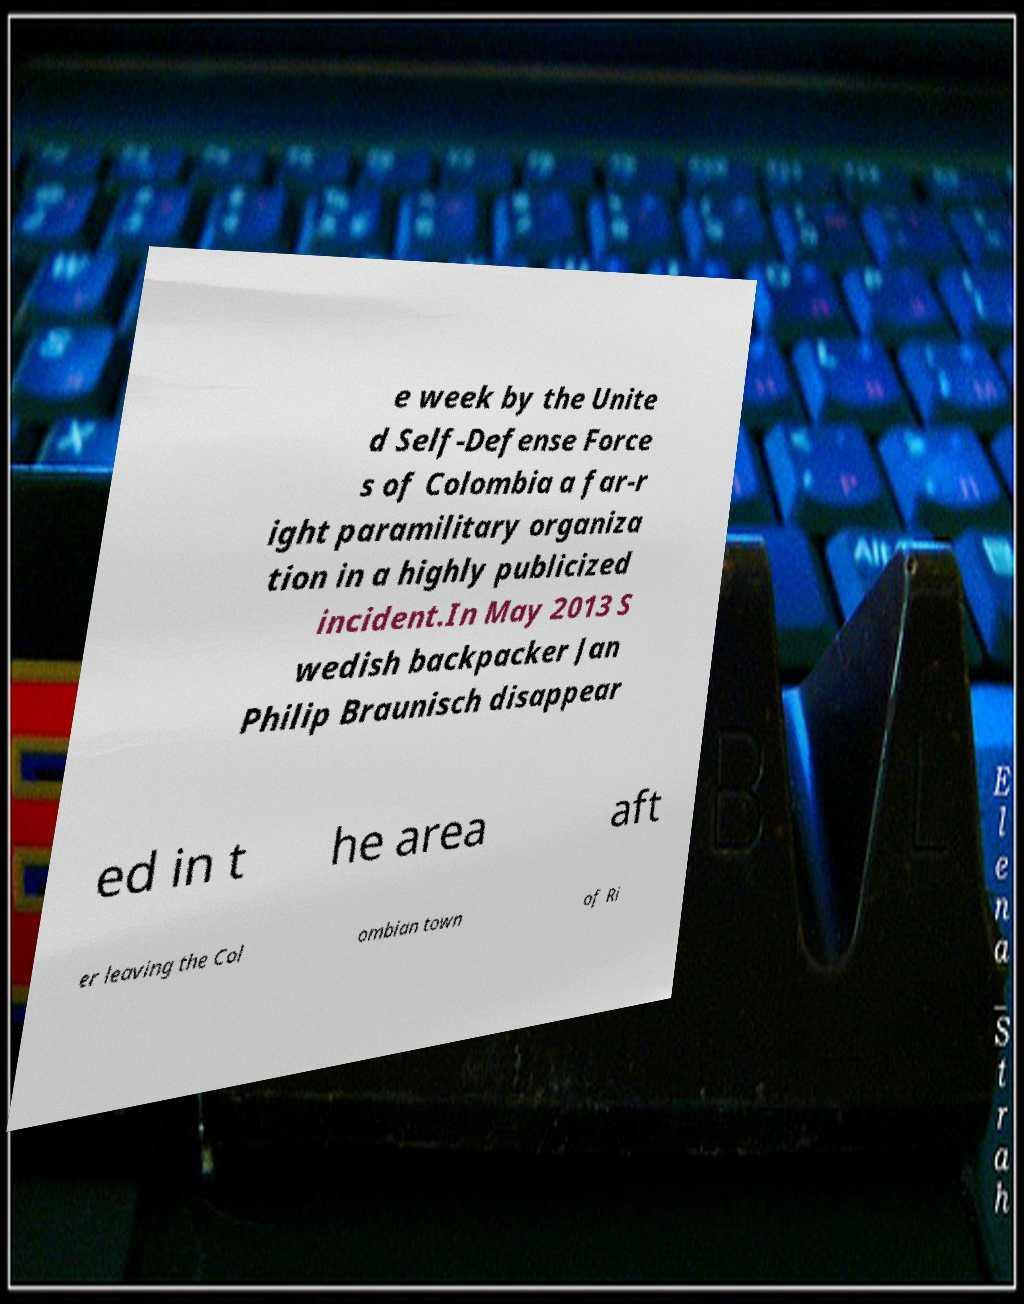Please identify and transcribe the text found in this image. e week by the Unite d Self-Defense Force s of Colombia a far-r ight paramilitary organiza tion in a highly publicized incident.In May 2013 S wedish backpacker Jan Philip Braunisch disappear ed in t he area aft er leaving the Col ombian town of Ri 